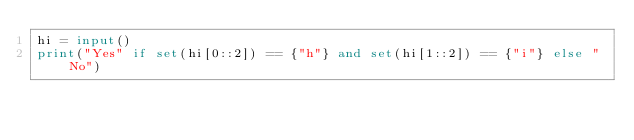Convert code to text. <code><loc_0><loc_0><loc_500><loc_500><_Python_>hi = input()
print("Yes" if set(hi[0::2]) == {"h"} and set(hi[1::2]) == {"i"} else "No")</code> 